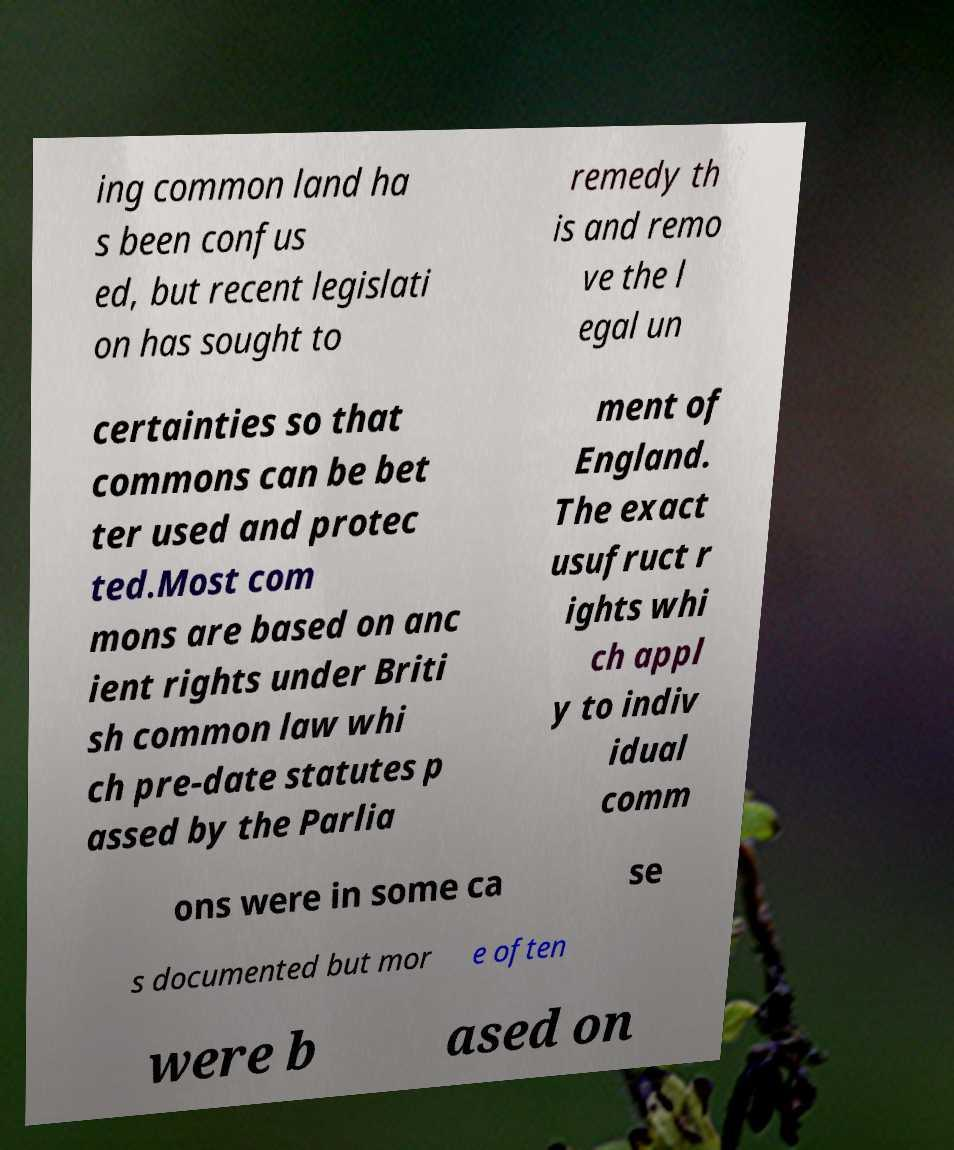There's text embedded in this image that I need extracted. Can you transcribe it verbatim? ing common land ha s been confus ed, but recent legislati on has sought to remedy th is and remo ve the l egal un certainties so that commons can be bet ter used and protec ted.Most com mons are based on anc ient rights under Briti sh common law whi ch pre-date statutes p assed by the Parlia ment of England. The exact usufruct r ights whi ch appl y to indiv idual comm ons were in some ca se s documented but mor e often were b ased on 